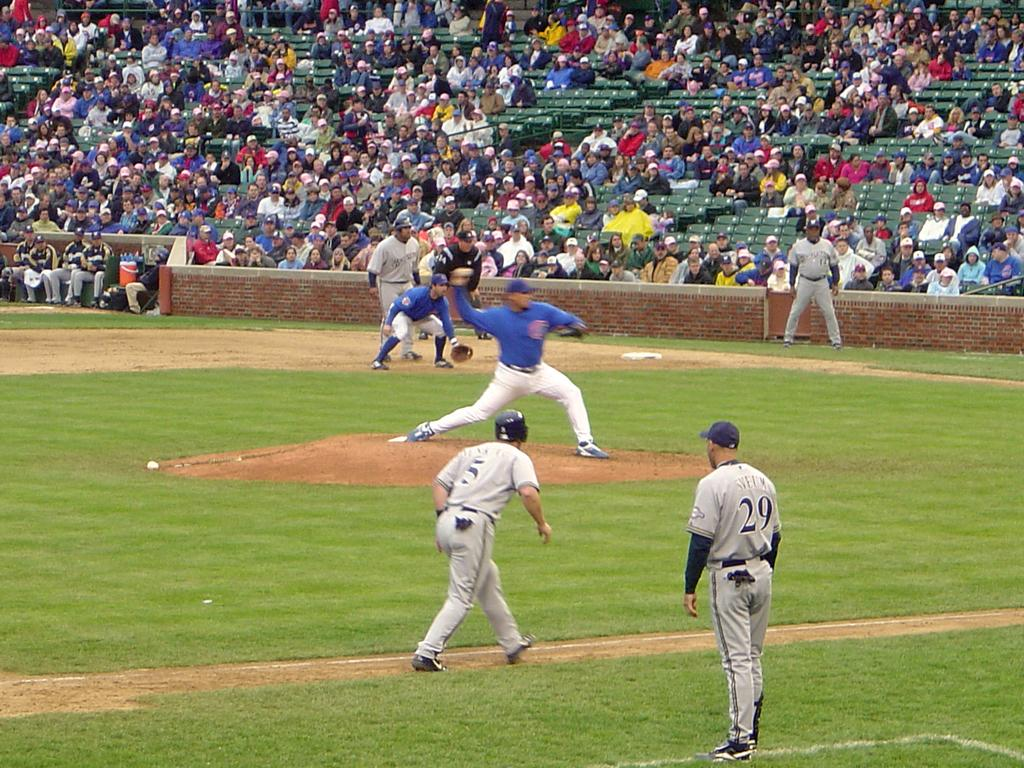<image>
Share a concise interpretation of the image provided. A baseball player standing on the sides with the number 29 on his back 